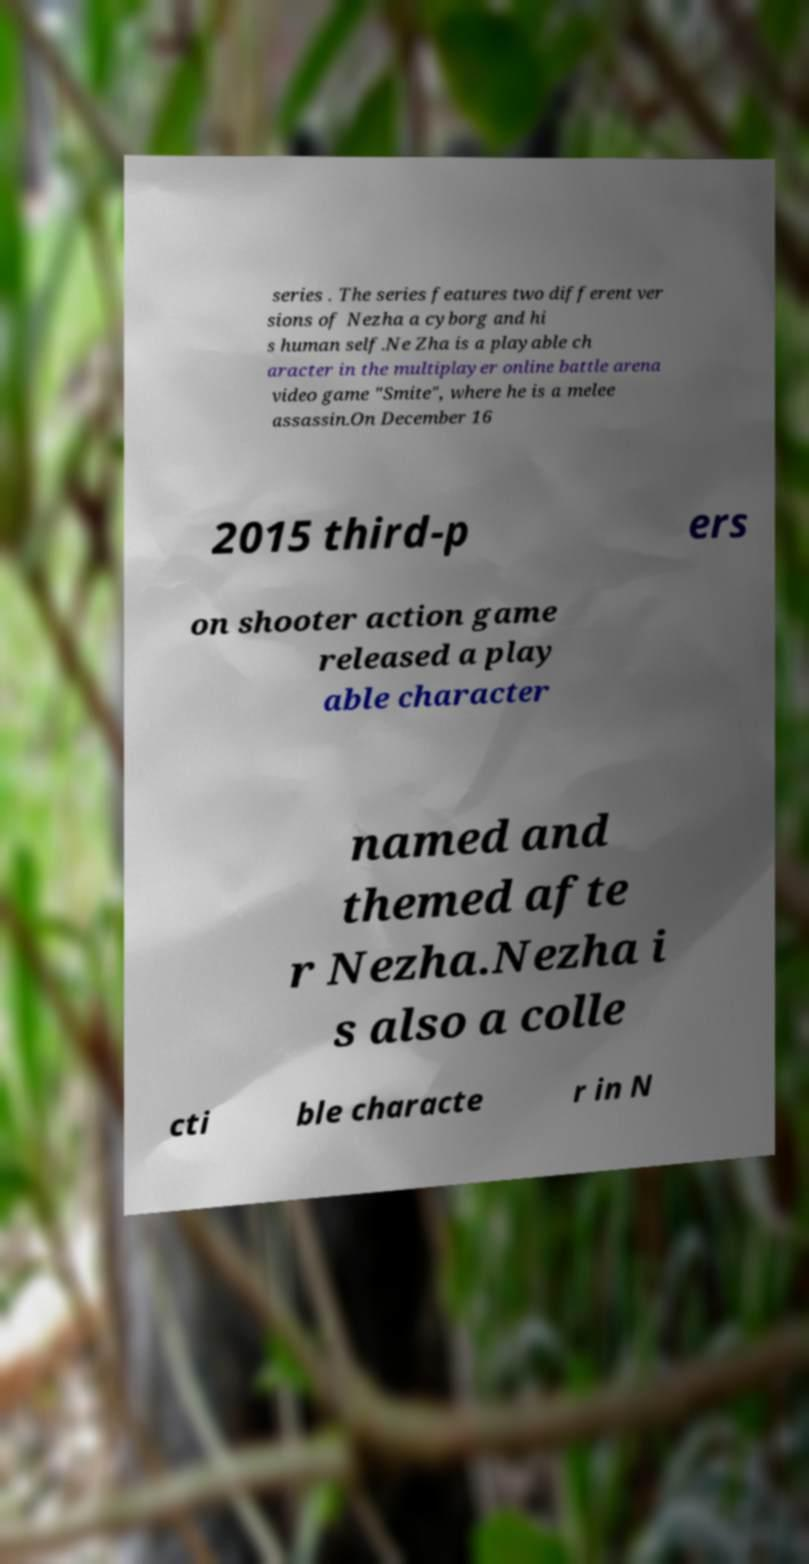Can you read and provide the text displayed in the image?This photo seems to have some interesting text. Can you extract and type it out for me? series . The series features two different ver sions of Nezha a cyborg and hi s human self.Ne Zha is a playable ch aracter in the multiplayer online battle arena video game "Smite", where he is a melee assassin.On December 16 2015 third-p ers on shooter action game released a play able character named and themed afte r Nezha.Nezha i s also a colle cti ble characte r in N 